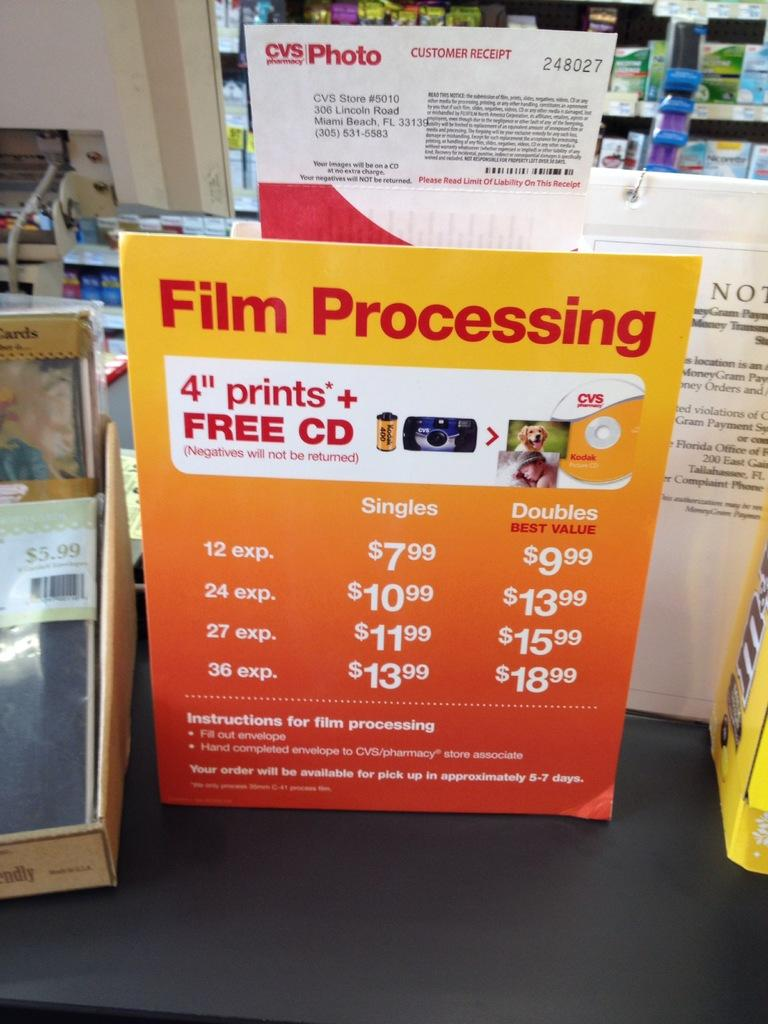<image>
Create a compact narrative representing the image presented. A brightly colored poster for film processing sits on a black counter. 